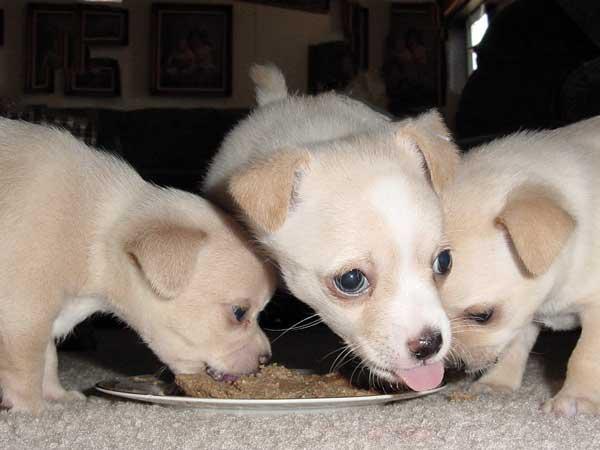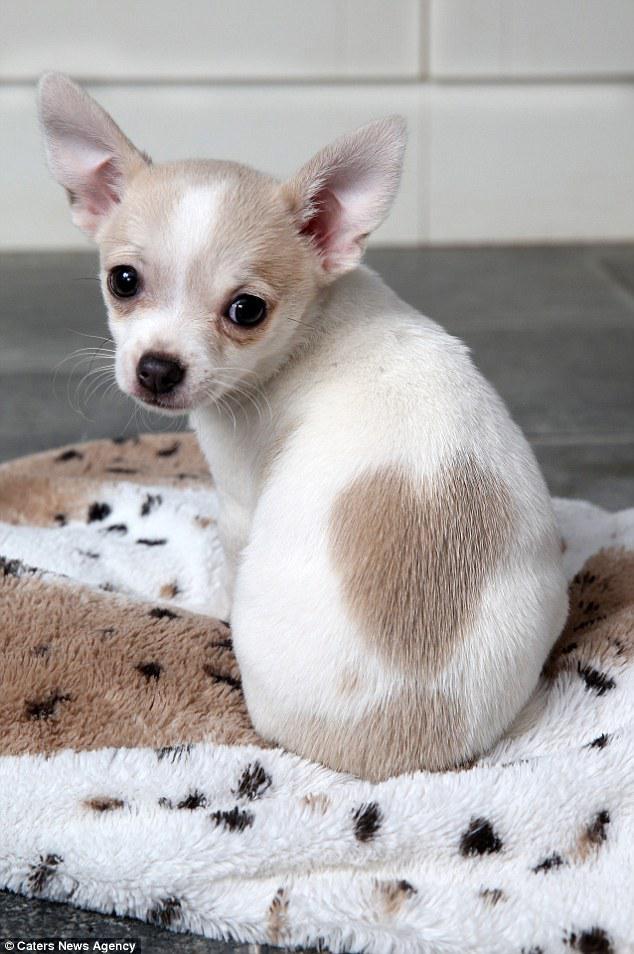The first image is the image on the left, the second image is the image on the right. Examine the images to the left and right. Is the description "A person is holding the dog in one of the images." accurate? Answer yes or no. No. The first image is the image on the left, the second image is the image on the right. For the images displayed, is the sentence "In total, the images contain four dogs, but do not contain the same number of dogs in each image." factually correct? Answer yes or no. Yes. 